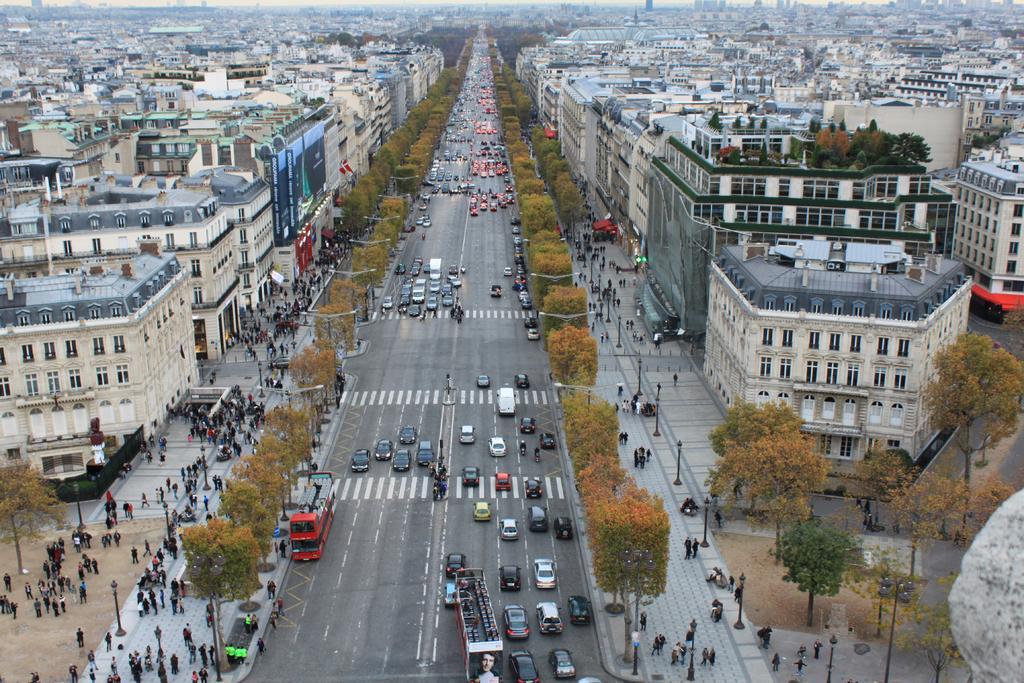How would you summarize this image in a sentence or two? In this image there are vehicles on the road. There are people. There are trees, buildings and light poles. 